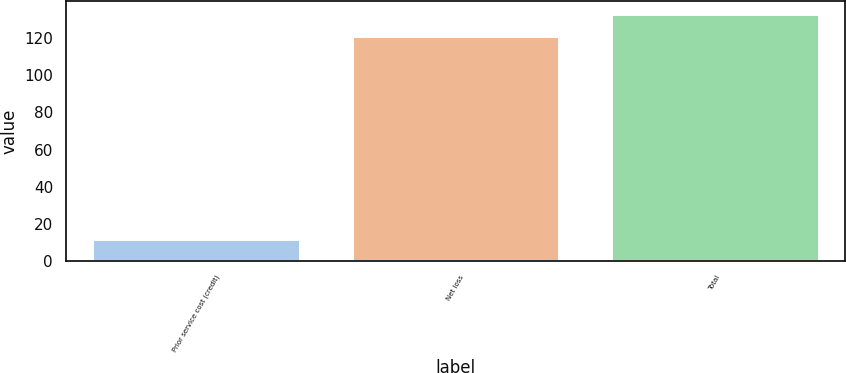Convert chart to OTSL. <chart><loc_0><loc_0><loc_500><loc_500><bar_chart><fcel>Prior service cost (credit)<fcel>Net loss<fcel>Total<nl><fcel>12<fcel>121<fcel>133.1<nl></chart> 